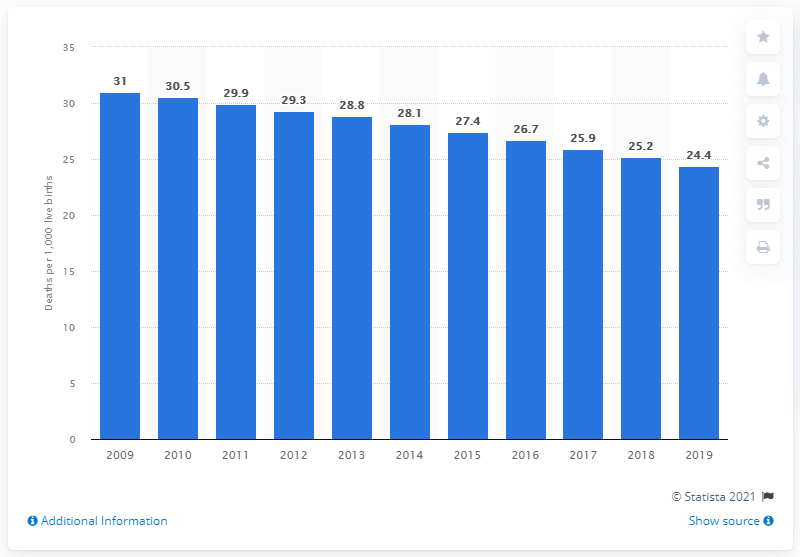Highlight a few significant elements in this photo. In 2019, the infant mortality rate in Guyana was 24.4. 